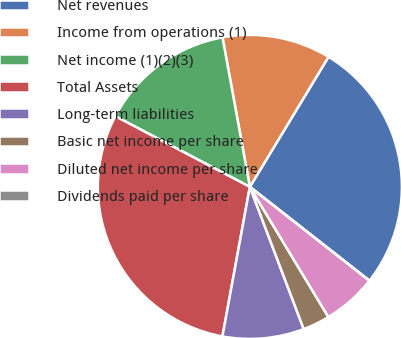Convert chart. <chart><loc_0><loc_0><loc_500><loc_500><pie_chart><fcel>Net revenues<fcel>Income from operations (1)<fcel>Net income (1)(2)(3)<fcel>Total Assets<fcel>Long-term liabilities<fcel>Basic net income per share<fcel>Diluted net income per share<fcel>Dividends paid per share<nl><fcel>26.93%<fcel>11.54%<fcel>14.42%<fcel>29.81%<fcel>8.65%<fcel>2.88%<fcel>5.77%<fcel>0.0%<nl></chart> 